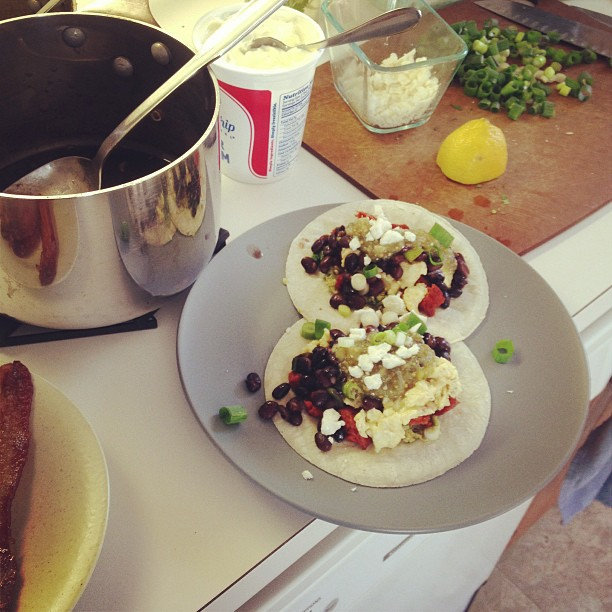Extract all visible text content from this image. up Nutr 